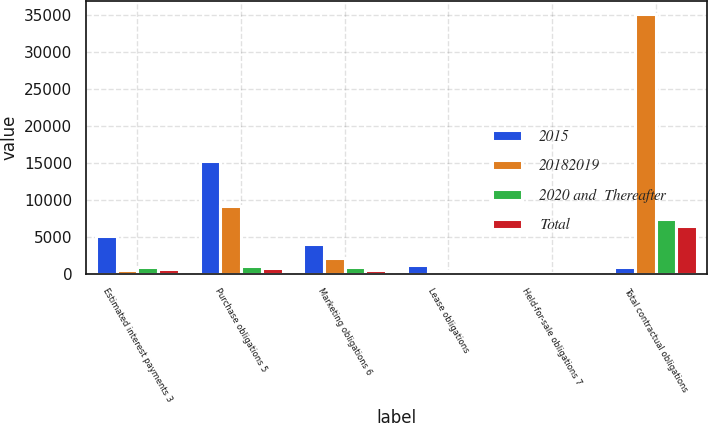<chart> <loc_0><loc_0><loc_500><loc_500><stacked_bar_chart><ecel><fcel>Estimated interest payments 3<fcel>Purchase obligations 5<fcel>Marketing obligations 6<fcel>Lease obligations<fcel>Held-for-sale obligations 7<fcel>Total contractual obligations<nl><fcel>2015<fcel>5084<fcel>15295<fcel>4043<fcel>1162<fcel>63<fcel>908<nl><fcel>20182019<fcel>473<fcel>9166<fcel>2143<fcel>269<fcel>28<fcel>35138<nl><fcel>2020 and  Thereafter<fcel>908<fcel>1028<fcel>944<fcel>344<fcel>17<fcel>7326<nl><fcel>Total<fcel>675<fcel>764<fcel>438<fcel>217<fcel>10<fcel>6431<nl></chart> 